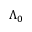<formula> <loc_0><loc_0><loc_500><loc_500>\Lambda _ { 0 }</formula> 